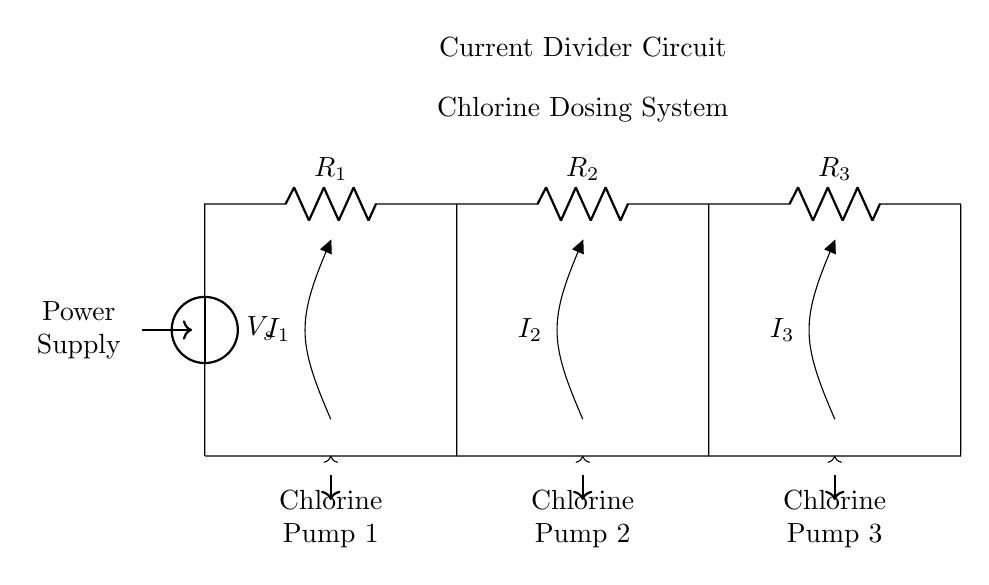What type of circuit is shown in the diagram? The circuit type is a current divider, characterized by branching paths for current flow, where each path represents a chlorine pump in this application.
Answer: Current divider What is the source voltage in this circuit? The source voltage is denoted as V_s in the diagram. It is the supply voltage powering the entire circuit and is located at the top left in the diagram.
Answer: V_s How many chlorine pumps are indicated in the circuit? The circuit diagram shows three chlorine pumps, each represented in separate branches of the current divider circuit. They are labeled as Chlorine Pump 1, Chlorine Pump 2, and Chlorine Pump 3.
Answer: Three Which component in the circuit is responsible for the control of current flow? The resistances R_1, R_2, and R_3 determine the division of current among the chlorine pumps based on their resistance values; lower resistance would allow more current to flow through that path.
Answer: Resistors What can be inferred about the function of the resistors in a current divider? The resistors in a current divider impact the distribution of current among the output branches. Their values dictate how much of the total current from the source (V_s) each branch receives. The current in each path is inversely proportional to the resistance of that path.
Answer: Current distribution What does I_1 represent in this current divider circuit? I_1 represents the current flowing through Chlorine Pump 1, which is one of the outputs from the current divider. This current can be calculated based on the total current and the values of the resistances in the circuit.
Answer: Current through Pump 1 